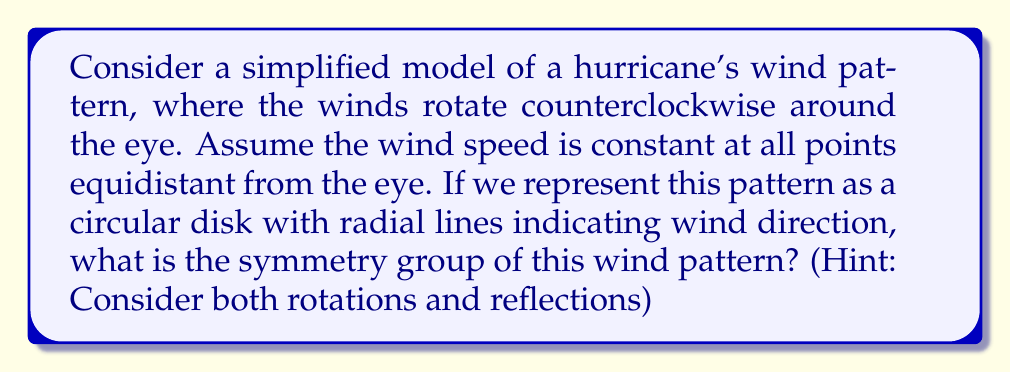Solve this math problem. To determine the symmetry group of the hurricane's wind pattern, we need to consider all transformations that leave the pattern unchanged. Let's approach this step-by-step:

1. Rotational symmetry:
   The wind pattern is rotationally symmetric about the center (eye) of the hurricane. Any rotation about the center will leave the pattern unchanged. This means we have continuous rotational symmetry, represented by the group $SO(2)$, the special orthogonal group in two dimensions.

2. Reflection symmetry:
   Unlike a simple circular disk, the wind pattern has directionality (counterclockwise rotation). A reflection would reverse this direction, changing the pattern from counterclockwise to clockwise. Therefore, there are no reflection symmetries.

3. Translation symmetry:
   The pattern is centered on the eye of the hurricane and does not have translational symmetry.

4. Formal group structure:
   The symmetry group is isomorphic to $SO(2)$, which can be parameterized by the angle of rotation $\theta$:

   $$SO(2) = \left\{\begin{pmatrix}\cos\theta & -\sin\theta \\ \sin\theta & \cos\theta\end{pmatrix} : \theta \in [0, 2\pi)\right\}$$

   This group is abelian (commutative), continuous, and compact.

5. Physical interpretation:
   In meteorological terms, this symmetry reflects the fact that the wind pattern of a hurricane looks the same regardless of the angle from which it's viewed, as long as we're looking down on it from above.

Therefore, the symmetry group of the hurricane's wind pattern is $SO(2)$, representing all possible rotations about the center of the hurricane.
Answer: The symmetry group of the hurricane's wind pattern is $SO(2)$, the special orthogonal group in two dimensions, representing continuous rotational symmetry about the center. 